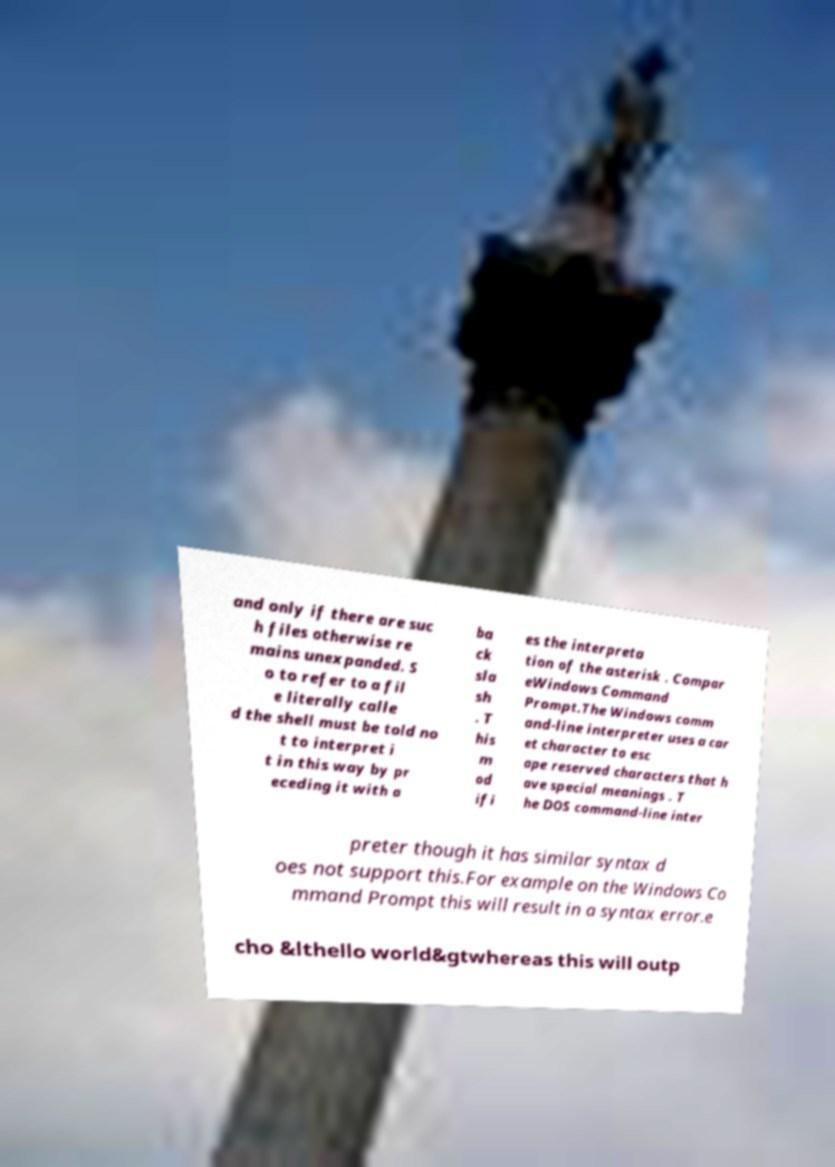Can you read and provide the text displayed in the image?This photo seems to have some interesting text. Can you extract and type it out for me? and only if there are suc h files otherwise re mains unexpanded. S o to refer to a fil e literally calle d the shell must be told no t to interpret i t in this way by pr eceding it with a ba ck sla sh . T his m od ifi es the interpreta tion of the asterisk . Compar eWindows Command Prompt.The Windows comm and-line interpreter uses a car et character to esc ape reserved characters that h ave special meanings . T he DOS command-line inter preter though it has similar syntax d oes not support this.For example on the Windows Co mmand Prompt this will result in a syntax error.e cho &lthello world&gtwhereas this will outp 